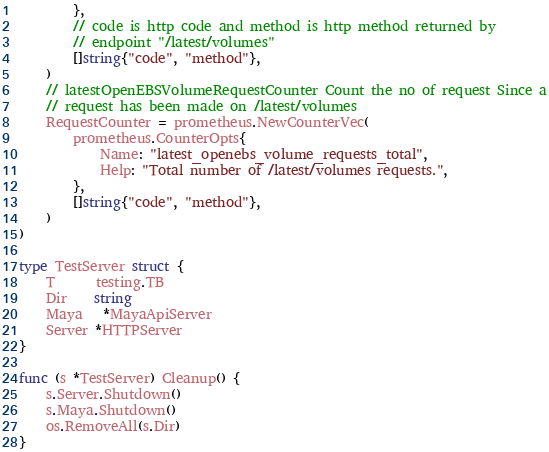Convert code to text. <code><loc_0><loc_0><loc_500><loc_500><_Go_>		},
		// code is http code and method is http method returned by
		// endpoint "/latest/volumes"
		[]string{"code", "method"},
	)
	// latestOpenEBSVolumeRequestCounter Count the no of request Since a
	// request has been made on /latest/volumes
	RequestCounter = prometheus.NewCounterVec(
		prometheus.CounterOpts{
			Name: "latest_openebs_volume_requests_total",
			Help: "Total number of /latest/volumes requests.",
		},
		[]string{"code", "method"},
	)
)

type TestServer struct {
	T      testing.TB
	Dir    string
	Maya   *MayaApiServer
	Server *HTTPServer
}

func (s *TestServer) Cleanup() {
	s.Server.Shutdown()
	s.Maya.Shutdown()
	os.RemoveAll(s.Dir)
}
</code> 